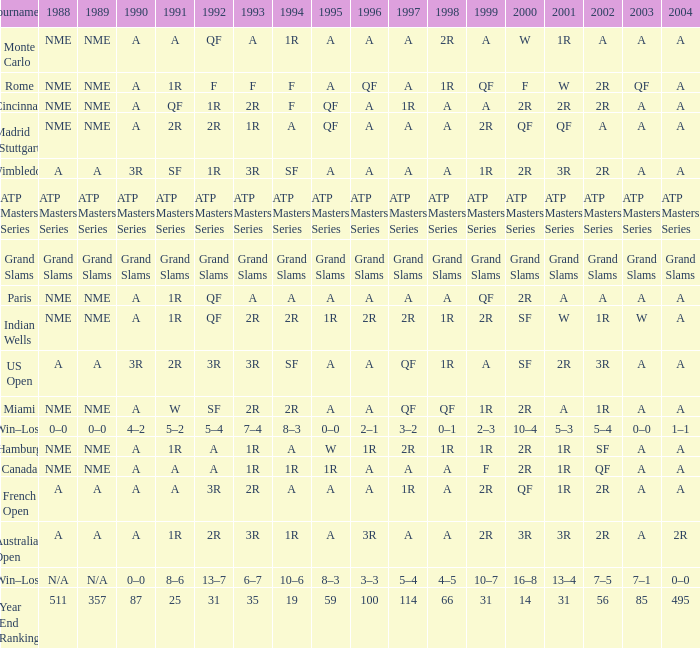What shows for 1992 when 2001 is 1r, 1994 is 1r, and the 2002 is qf? A. 